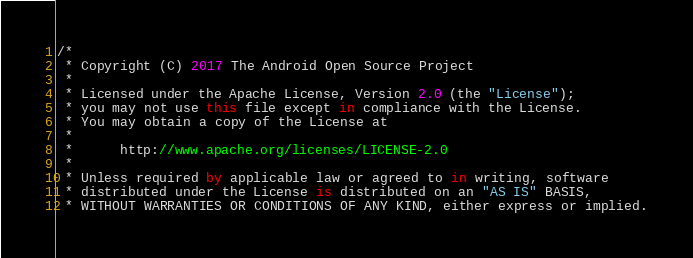Convert code to text. <code><loc_0><loc_0><loc_500><loc_500><_Kotlin_>/*
 * Copyright (C) 2017 The Android Open Source Project
 *
 * Licensed under the Apache License, Version 2.0 (the "License");
 * you may not use this file except in compliance with the License.
 * You may obtain a copy of the License at
 *
 *      http://www.apache.org/licenses/LICENSE-2.0
 *
 * Unless required by applicable law or agreed to in writing, software
 * distributed under the License is distributed on an "AS IS" BASIS,
 * WITHOUT WARRANTIES OR CONDITIONS OF ANY KIND, either express or implied.</code> 